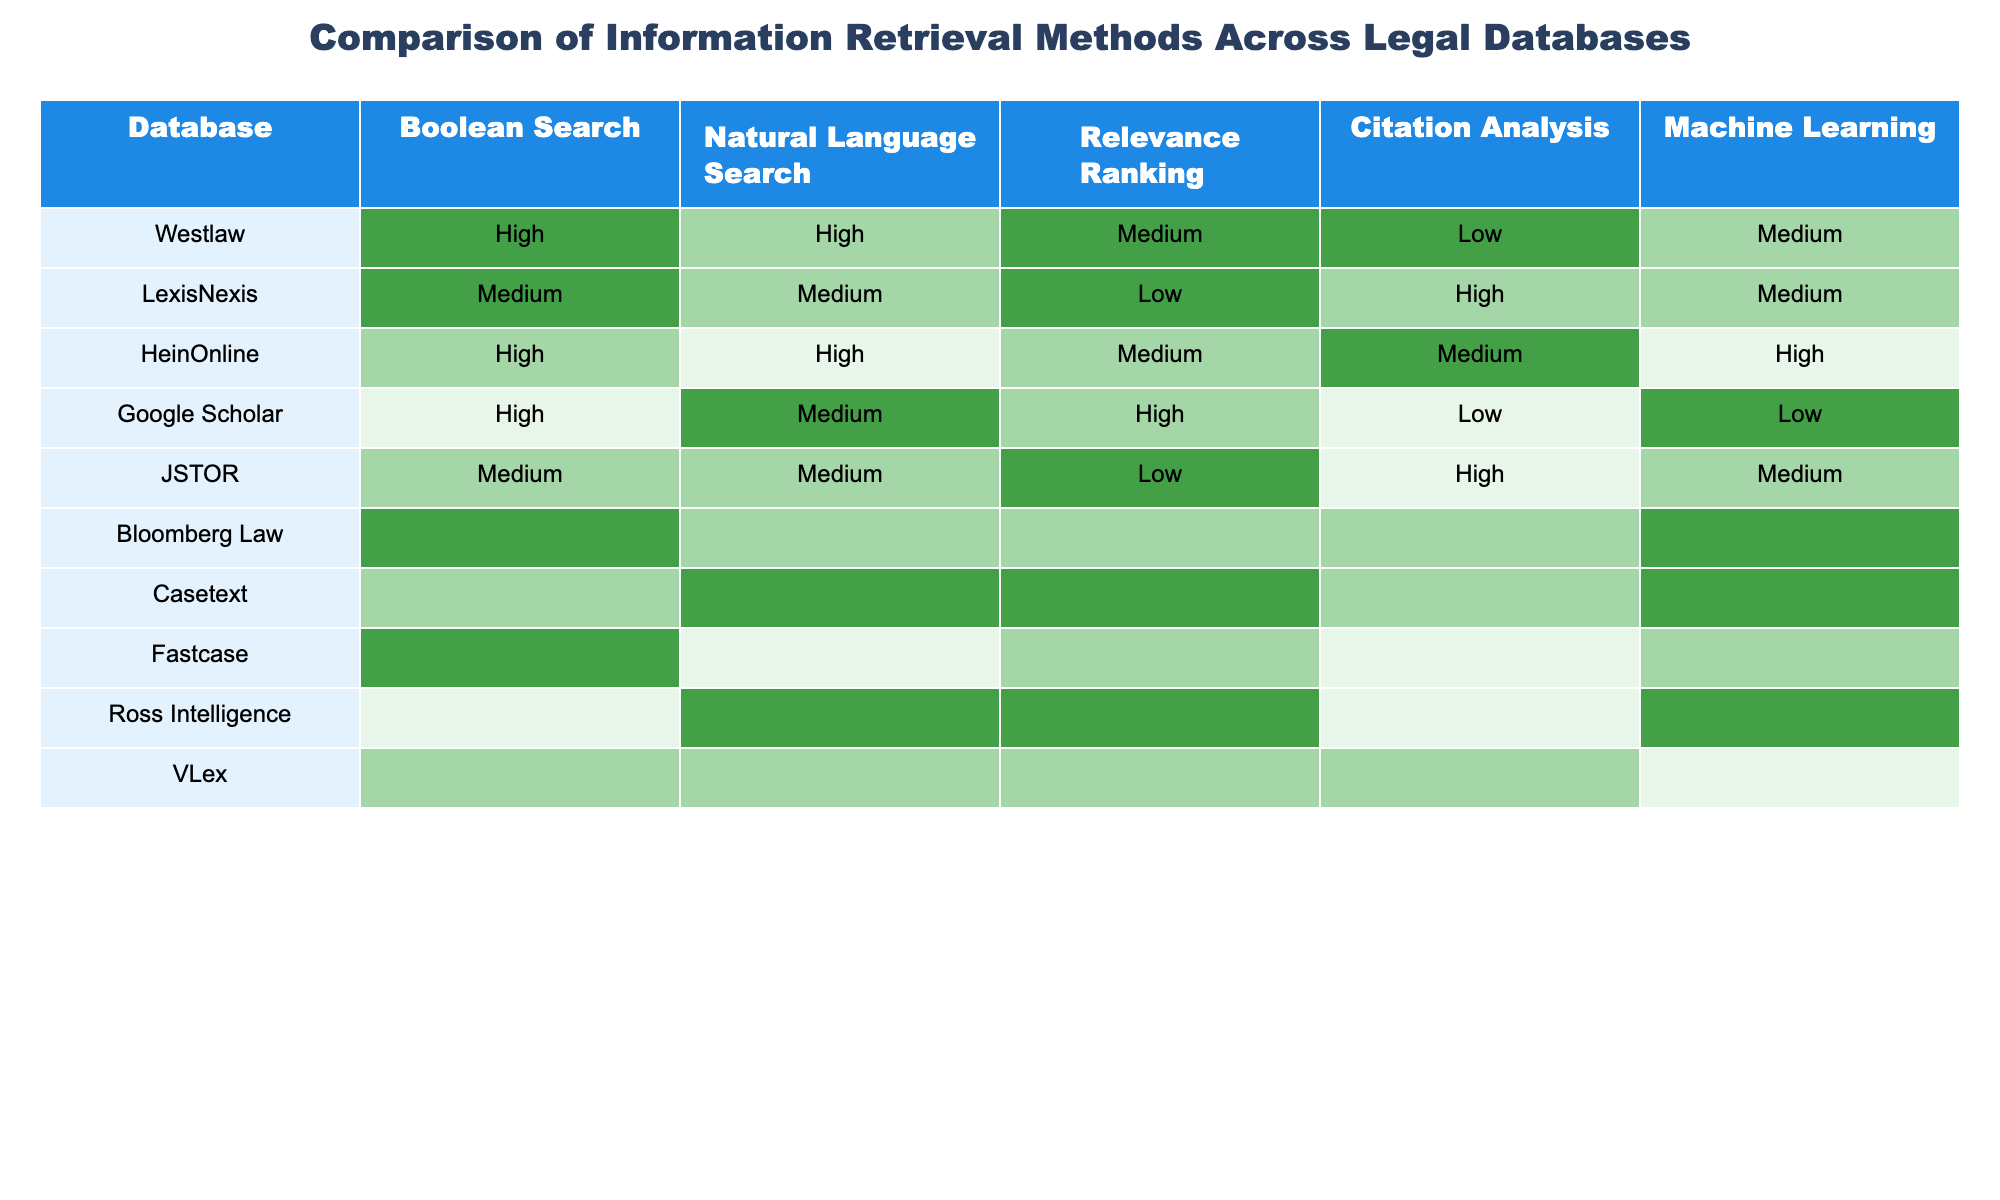What is the retrieval method with the highest ranking in Westlaw? In the Westlaw row, the retrieval method with the highest ranking is Boolean Search, which is marked as "High."
Answer: Boolean Search Which database has the best Natural Language Search capability? Comparing the Natural Language Search column across all databases, Google Scholar stands out with a "High" rating.
Answer: Google Scholar How many databases have a "Medium" rating in Citation Analysis? Reviewing the Citation Analysis column, there are four databases (HeinOnline, Bloomberg Law, VLex, and Casetext) with a "Medium" rating.
Answer: Four Which retrieval method is rated as "Low" in Fastcase? Fastcase has a "Low" rating for Natural Language Search.
Answer: Natural Language Search Which database has the lowest rankings for both Boolean Search and Machine Learning? Looking at the Boolean Search and Machine Learning columns, HeinOnline has "Medium" for Boolean Search and "Low" for Machine Learning, making it the database with the lowest rankings in these two methods.
Answer: HeinOnline Is there any database that has all retrieval methods rated as "Medium" or higher? A careful examination shows that no database has all retrieval methods rated as "Medium" or higher, as they vary across different methods.
Answer: No Which retrieval method is commonly rated "High" across most databases? By checking the columns, Boolean Search is rated "High" in six out of the ten databases, showing its common high rating.
Answer: Boolean Search What is the average rating for Citation Analysis across all listed databases? Summing the ratings (High=3, Medium=2, Low=1) for Citation Analysis, the values are (High, Medium, Medium, Low, Low, Medium, Medium, High, Medium, Medium) = 5x2 + 4x3 + 3x1 = 22/10 = 2.2, which converts to approximately "Medium."
Answer: Medium Which retrieval method has the highest variability in ratings across the databases? The review shows that Natural Language Search has the most diverse ratings, with values ranging from "Low" (HeinOnline, Fastcase, and Ross Intelligence) to "High" (Google Scholar and Casetext).
Answer: Natural Language Search Are the rankings for Machine Learning more favorable in Casetext than in HeinOnline? In Casetext, Machine Learning is rated "High," while in HeinOnline, it is rated "Low." Thus, the rankings for Machine Learning are indeed more favorable in Casetext.
Answer: Yes 